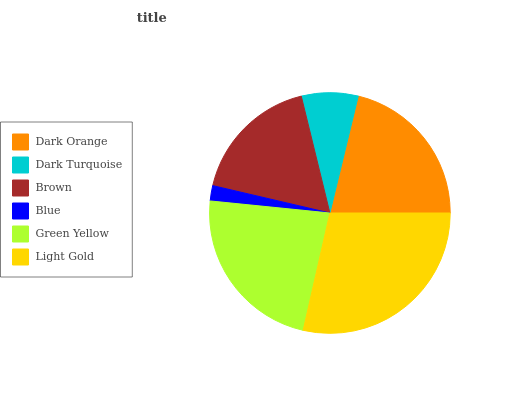Is Blue the minimum?
Answer yes or no. Yes. Is Light Gold the maximum?
Answer yes or no. Yes. Is Dark Turquoise the minimum?
Answer yes or no. No. Is Dark Turquoise the maximum?
Answer yes or no. No. Is Dark Orange greater than Dark Turquoise?
Answer yes or no. Yes. Is Dark Turquoise less than Dark Orange?
Answer yes or no. Yes. Is Dark Turquoise greater than Dark Orange?
Answer yes or no. No. Is Dark Orange less than Dark Turquoise?
Answer yes or no. No. Is Dark Orange the high median?
Answer yes or no. Yes. Is Brown the low median?
Answer yes or no. Yes. Is Brown the high median?
Answer yes or no. No. Is Dark Turquoise the low median?
Answer yes or no. No. 